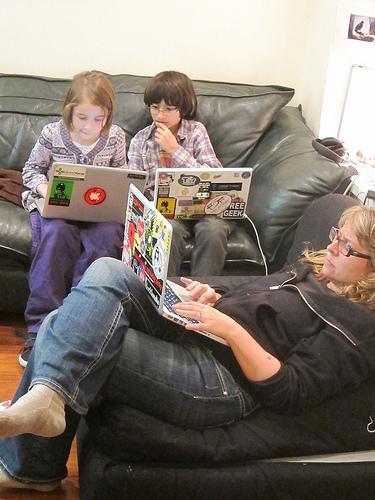How many people are there?
Give a very brief answer. 3. 